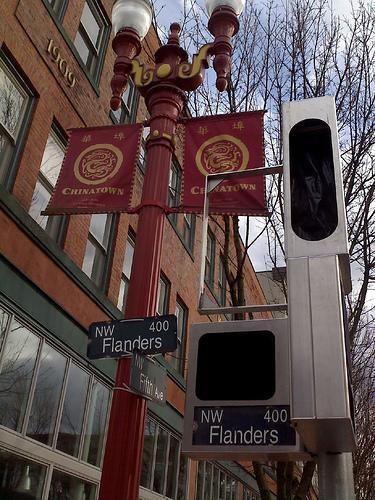How many flags are there?
Give a very brief answer. 2. 